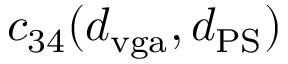Convert formula to latex. <formula><loc_0><loc_0><loc_500><loc_500>c _ { 3 4 } ( d _ { v g a } , d _ { P S } )</formula> 